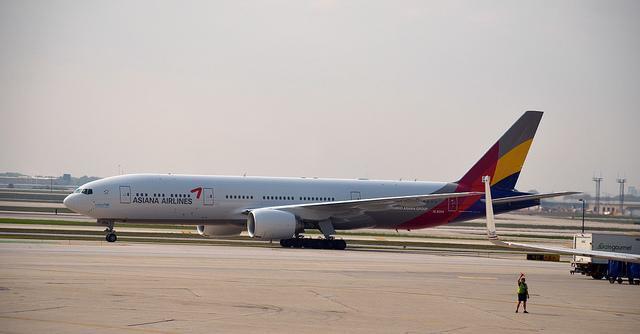Why is the man holding up an orange object?
Make your selection and explain in format: 'Answer: answer
Rationale: rationale.'
Options: Direct traffic, to eat, to fight, to dance. Answer: direct traffic.
Rationale: The man has an orange object so the planes can see him. 